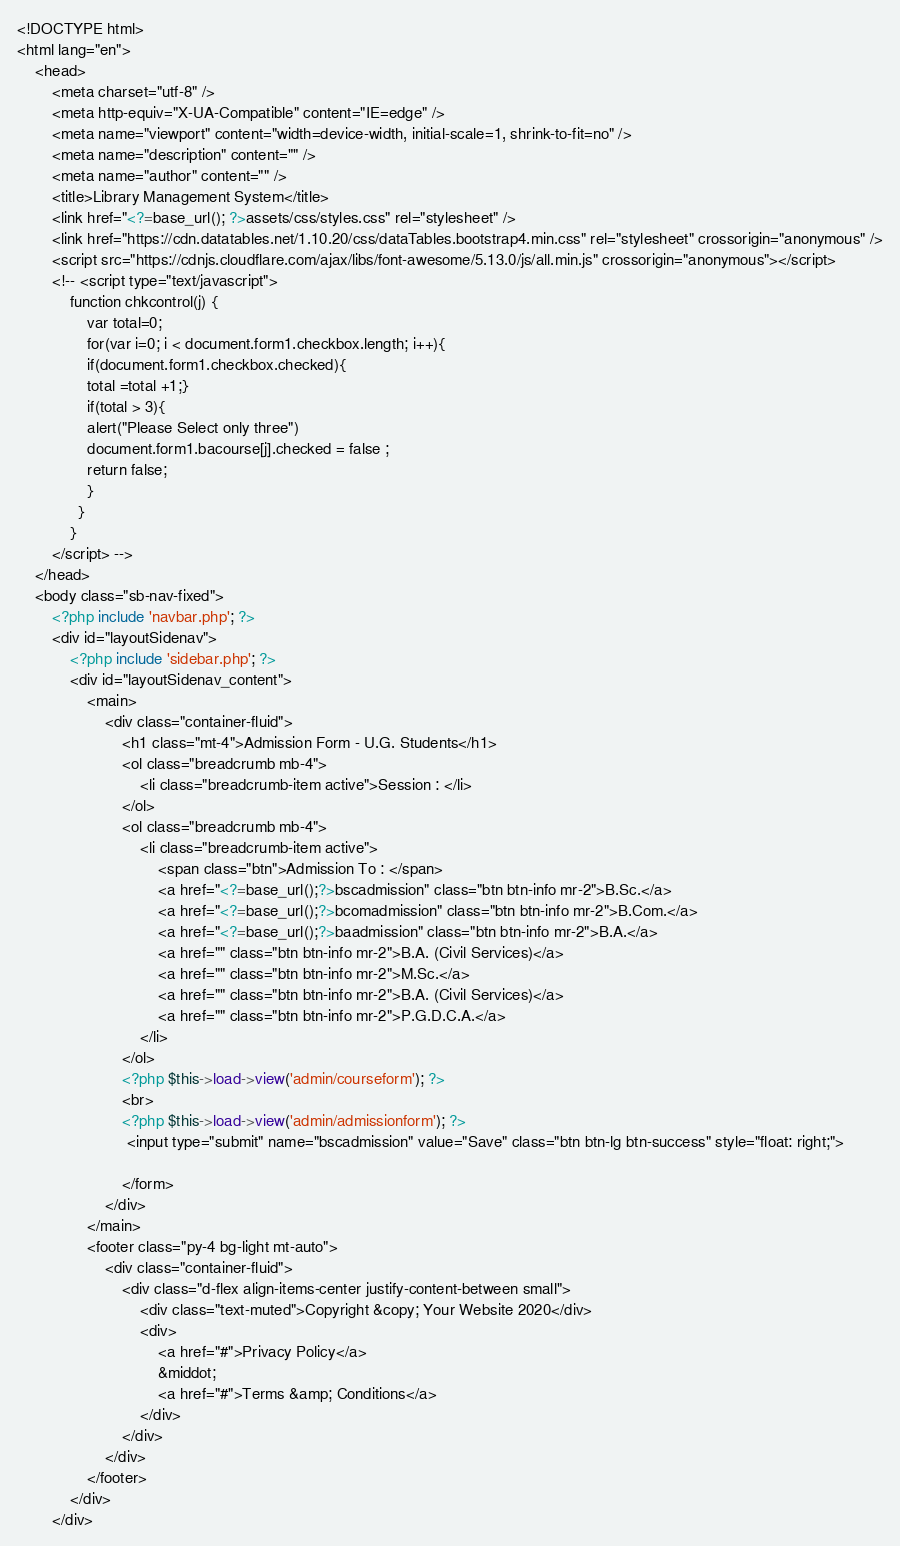<code> <loc_0><loc_0><loc_500><loc_500><_PHP_><!DOCTYPE html>
<html lang="en">
    <head>
        <meta charset="utf-8" />
        <meta http-equiv="X-UA-Compatible" content="IE=edge" />
        <meta name="viewport" content="width=device-width, initial-scale=1, shrink-to-fit=no" />
        <meta name="description" content="" />
        <meta name="author" content="" />
        <title>Library Management System</title>
        <link href="<?=base_url(); ?>assets/css/styles.css" rel="stylesheet" />
        <link href="https://cdn.datatables.net/1.10.20/css/dataTables.bootstrap4.min.css" rel="stylesheet" crossorigin="anonymous" />
        <script src="https://cdnjs.cloudflare.com/ajax/libs/font-awesome/5.13.0/js/all.min.js" crossorigin="anonymous"></script>
        <!-- <script type="text/javascript">
            function chkcontrol(j) {
                var total=0;
                for(var i=0; i < document.form1.checkbox.length; i++){
                if(document.form1.checkbox.checked){
                total =total +1;}
                if(total > 3){
                alert("Please Select only three") 
                document.form1.bacourse[j].checked = false ;
                return false;
                }
              }
            }
        </script> -->
    </head>
    <body class="sb-nav-fixed">
        <?php include 'navbar.php'; ?>
        <div id="layoutSidenav">
            <?php include 'sidebar.php'; ?>
            <div id="layoutSidenav_content">
                <main>
                    <div class="container-fluid">
                        <h1 class="mt-4">Admission Form - U.G. Students</h1>
                        <ol class="breadcrumb mb-4">
                            <li class="breadcrumb-item active">Session : </li>
                        </ol>
                        <ol class="breadcrumb mb-4">
                            <li class="breadcrumb-item active">
                                <span class="btn">Admission To : </span>
                                <a href="<?=base_url();?>bscadmission" class="btn btn-info mr-2">B.Sc.</a>
                                <a href="<?=base_url();?>bcomadmission" class="btn btn-info mr-2">B.Com.</a>
                                <a href="<?=base_url();?>baadmission" class="btn btn-info mr-2">B.A.</a>
                                <a href="" class="btn btn-info mr-2">B.A. (Civil Services)</a>
                                <a href="" class="btn btn-info mr-2">M.Sc.</a>
                                <a href="" class="btn btn-info mr-2">B.A. (Civil Services)</a>
                                <a href="" class="btn btn-info mr-2">P.G.D.C.A.</a>
                            </li>
                        </ol>
                        <?php $this->load->view('admin/courseform'); ?>
                        <br>
                        <?php $this->load->view('admin/admissionform'); ?>
                         <input type="submit" name="bscadmission" value="Save" class="btn btn-lg btn-success" style="float: right;">
                         
                        </form>                   
                    </div>
                </main>
                <footer class="py-4 bg-light mt-auto">
                    <div class="container-fluid">
                        <div class="d-flex align-items-center justify-content-between small">
                            <div class="text-muted">Copyright &copy; Your Website 2020</div>
                            <div>
                                <a href="#">Privacy Policy</a>
                                &middot;
                                <a href="#">Terms &amp; Conditions</a>
                            </div>
                        </div>
                    </div>
                </footer>
            </div>
        </div></code> 